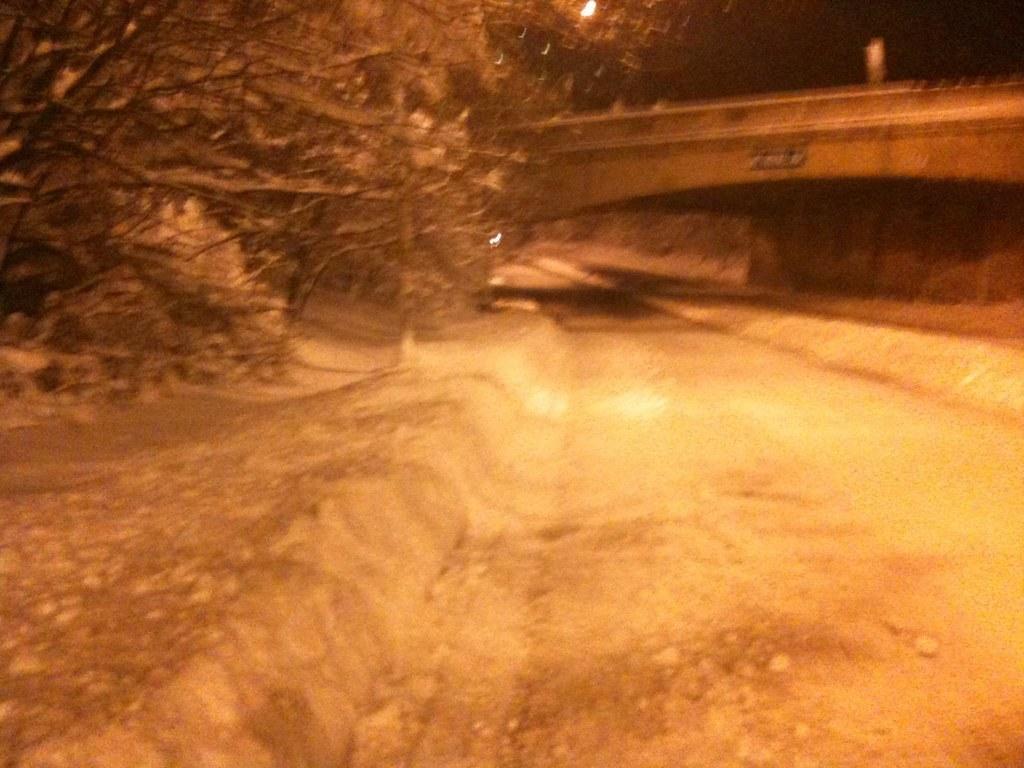How would you summarize this image in a sentence or two? In this picture we can see the bridge and trees. At the top there is a street light. At the bottom there is a road. At the top right corner there is a sky. 